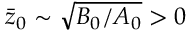<formula> <loc_0><loc_0><loc_500><loc_500>\ B a r { z } _ { 0 } \sim \sqrt { B _ { 0 } / A _ { 0 } } > 0</formula> 